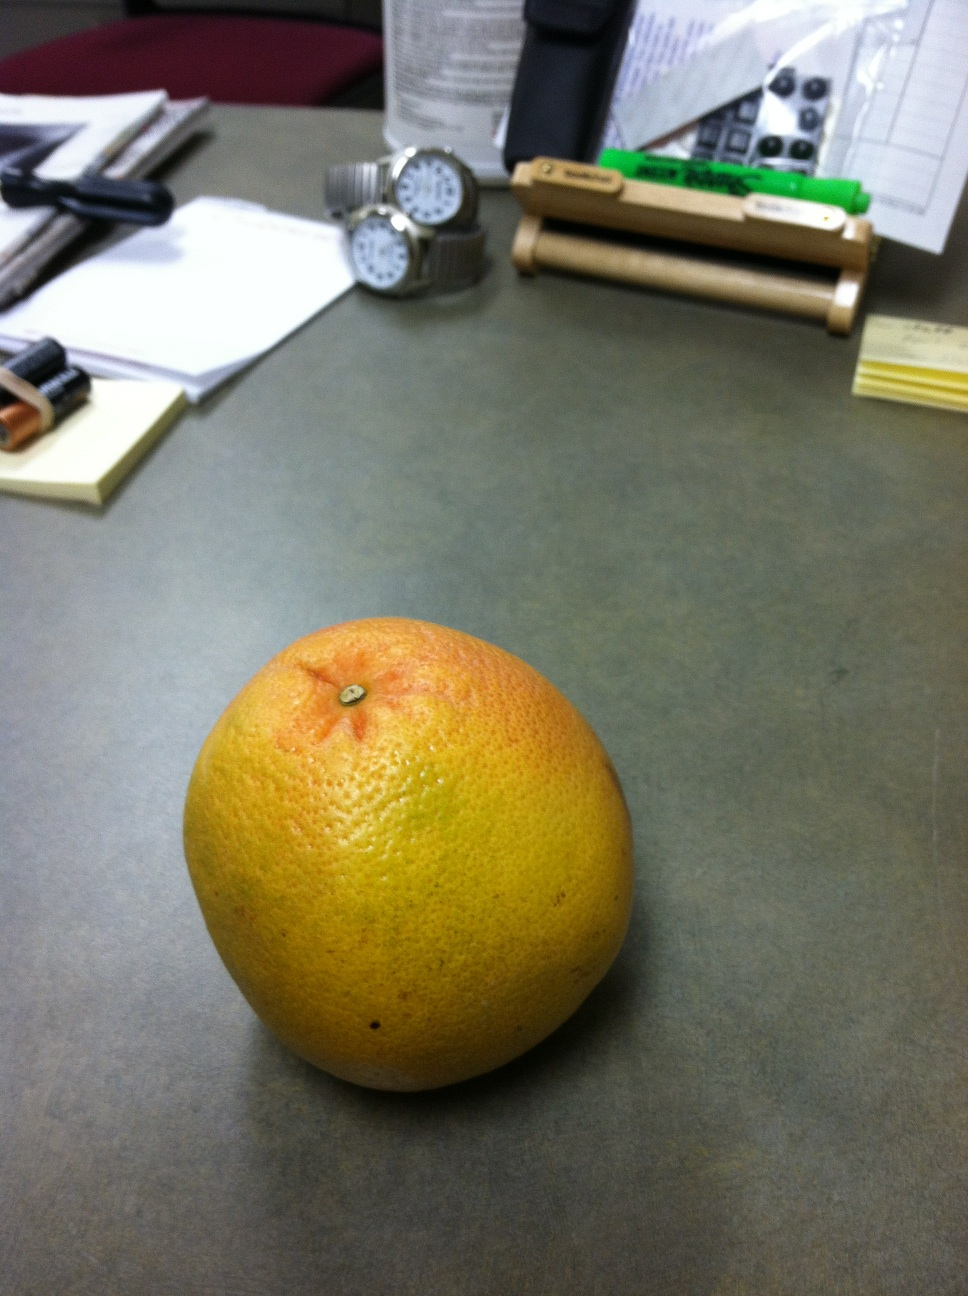Craft a creative story surrounding the items on the desk. Once upon a time, in an ordinary office, there was a desk with a secret. Every night, after the last person had left, the items on this desk came to life. The two watches, eternally locked in a race to see who could tell time more precisely, would tick-tock their way through the night, occasionally having philosophical discussions about the nature of time itself. The batteries, secretly tiny robots, would recharge and prepare for their next mission to power all the gadgets in the office. The grapefruit, a wise and ancient fruit, acted as the sage of the desk, providing advice to the watches and batteries. It had once been part of a magical orchard and retained some enchantment, which is why it never spoiled. The papers would gossip about office politics, sharing news about the humans and their peculiar habits. And if you listen closely enough, you might hear them at midnight, sharing tales of their day and secrets of their enchanted lives. 